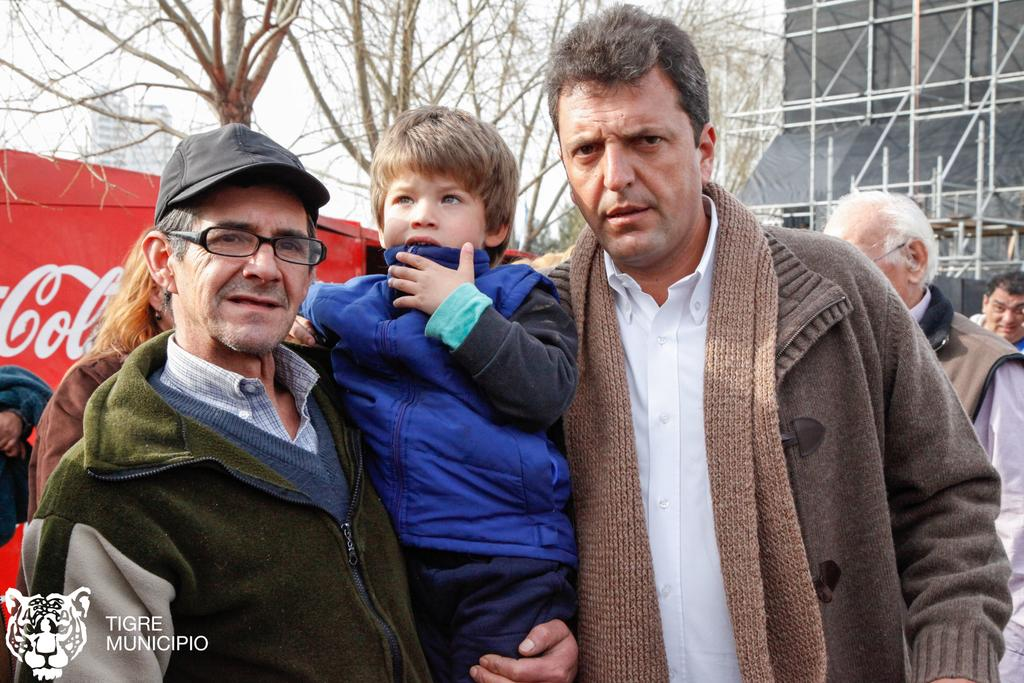What is happening in the image involving the people? There are people standing in the image, and a man is holding a kid in his hand. What are the people wearing in the image? The people are wearing jackets. What can be seen in the background of the image? There is a building and trees in the background of the image. What type of oil is being used by the committee in the image? There is no committee or oil present in the image. Can you describe the edge of the building in the image? The image does not provide a clear view of the building's edge. 